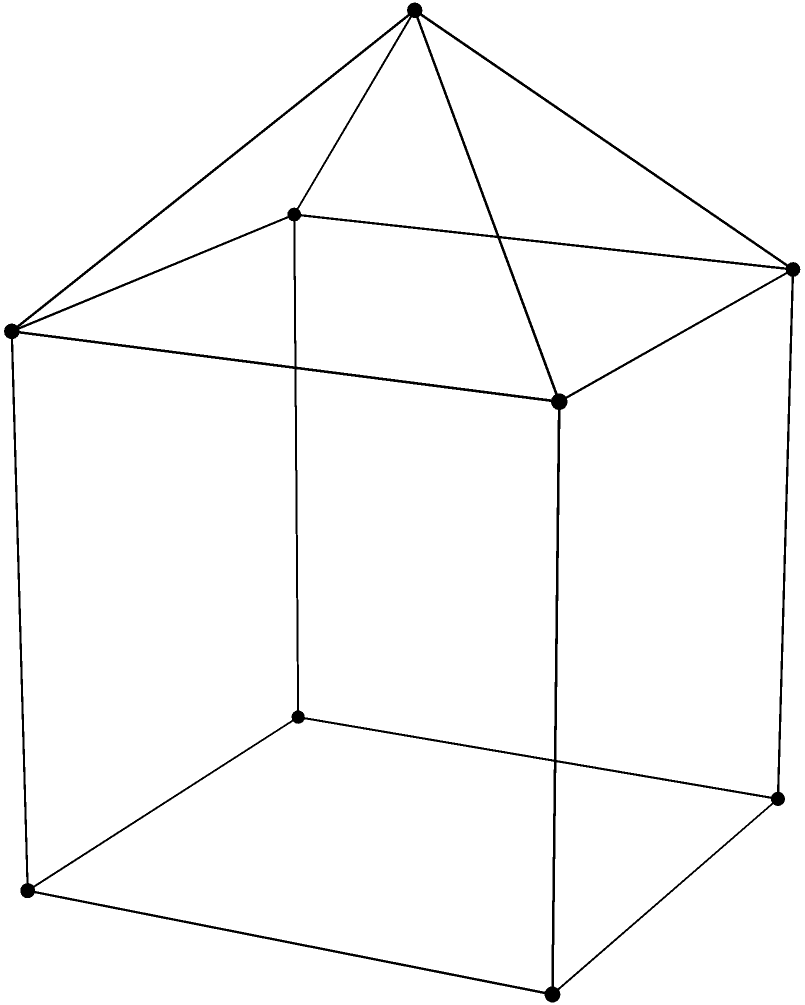Consider the polyhedron shown in the figure, which consists of a cube with a pyramid attached to its top face. How many faces, edges, and vertices does this polyhedron have? Express your answer as a triple $(f,e,v)$, where $f$ is the number of faces, $e$ is the number of edges, and $v$ is the number of vertices. Let's approach this systematically:

1. Vertices:
   - The cube has 8 vertices
   - The pyramid adds 1 new vertex (the apex)
   - Total vertices: $v = 8 + 1 = 9$

2. Faces:
   - The cube originally had 6 faces
   - We remove the top face of the cube
   - We add 4 triangular faces for the pyramid
   - Total faces: $f = 6 - 1 + 4 = 9$

3. Edges:
   - The cube originally had 12 edges
   - We add 4 new edges connecting the apex to the top vertices of the cube
   - Total edges: $e = 12 + 4 = 16$

We can verify this result using Euler's formula for convex polyhedra:
$v - e + f = 2$

Substituting our values:
$9 - 16 + 9 = 2$

This confirms that our count is correct.

Therefore, the polyhedron has 9 faces, 16 edges, and 9 vertices.
Answer: $(9,16,9)$ 